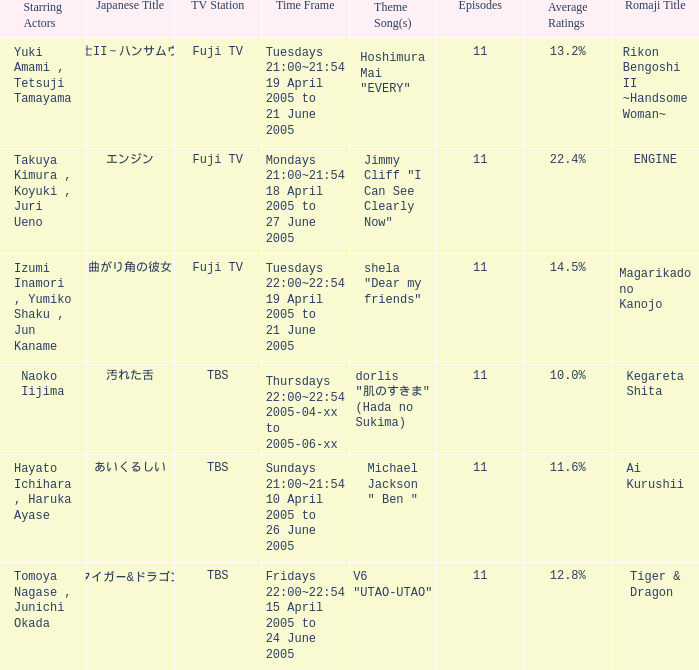Parse the full table. {'header': ['Starring Actors', 'Japanese Title', 'TV Station', 'Time Frame', 'Theme Song(s)', 'Episodes', 'Average Ratings', 'Romaji Title'], 'rows': [['Yuki Amami , Tetsuji Tamayama', '離婚弁護士II～ハンサムウーマン～', 'Fuji TV', 'Tuesdays 21:00~21:54 19 April 2005 to 21 June 2005', 'Hoshimura Mai "EVERY"', '11', '13.2%', 'Rikon Bengoshi II ~Handsome Woman~'], ['Takuya Kimura , Koyuki , Juri Ueno', 'エンジン', 'Fuji TV', 'Mondays 21:00~21:54 18 April 2005 to 27 June 2005', 'Jimmy Cliff "I Can See Clearly Now"', '11', '22.4%', 'ENGINE'], ['Izumi Inamori , Yumiko Shaku , Jun Kaname', '曲がり角の彼女', 'Fuji TV', 'Tuesdays 22:00~22:54 19 April 2005 to 21 June 2005', 'shela "Dear my friends"', '11', '14.5%', 'Magarikado no Kanojo'], ['Naoko Iijima', '汚れた舌', 'TBS', 'Thursdays 22:00~22:54 2005-04-xx to 2005-06-xx', 'dorlis "肌のすきま" (Hada no Sukima)', '11', '10.0%', 'Kegareta Shita'], ['Hayato Ichihara , Haruka Ayase', 'あいくるしい', 'TBS', 'Sundays 21:00~21:54 10 April 2005 to 26 June 2005', 'Michael Jackson " Ben "', '11', '11.6%', 'Ai Kurushii'], ['Tomoya Nagase , Junichi Okada', 'タイガー&ドラゴン', 'TBS', 'Fridays 22:00~22:54 15 April 2005 to 24 June 2005', 'V6 "UTAO-UTAO"', '11', '12.8%', 'Tiger & Dragon']]} What is maximum number of episodes for a show? 11.0. 